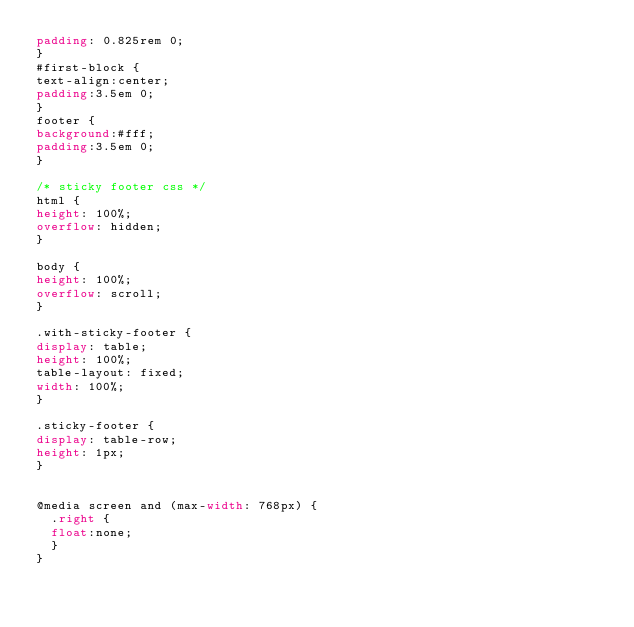Convert code to text. <code><loc_0><loc_0><loc_500><loc_500><_CSS_>padding: 0.825rem 0;
}
#first-block {
text-align:center;
padding:3.5em 0;
}
footer {
background:#fff;
padding:3.5em 0;
}

/* sticky footer css */
html {
height: 100%;
overflow: hidden;
}
 
body {
height: 100%;
overflow: scroll;
}
 
.with-sticky-footer {
display: table;
height: 100%;
table-layout: fixed;
width: 100%; 
}
 
.sticky-footer {
display: table-row;
height: 1px;
} 


@media screen and (max-width: 768px) {
  .right {
  float:none;
  }
}</code> 